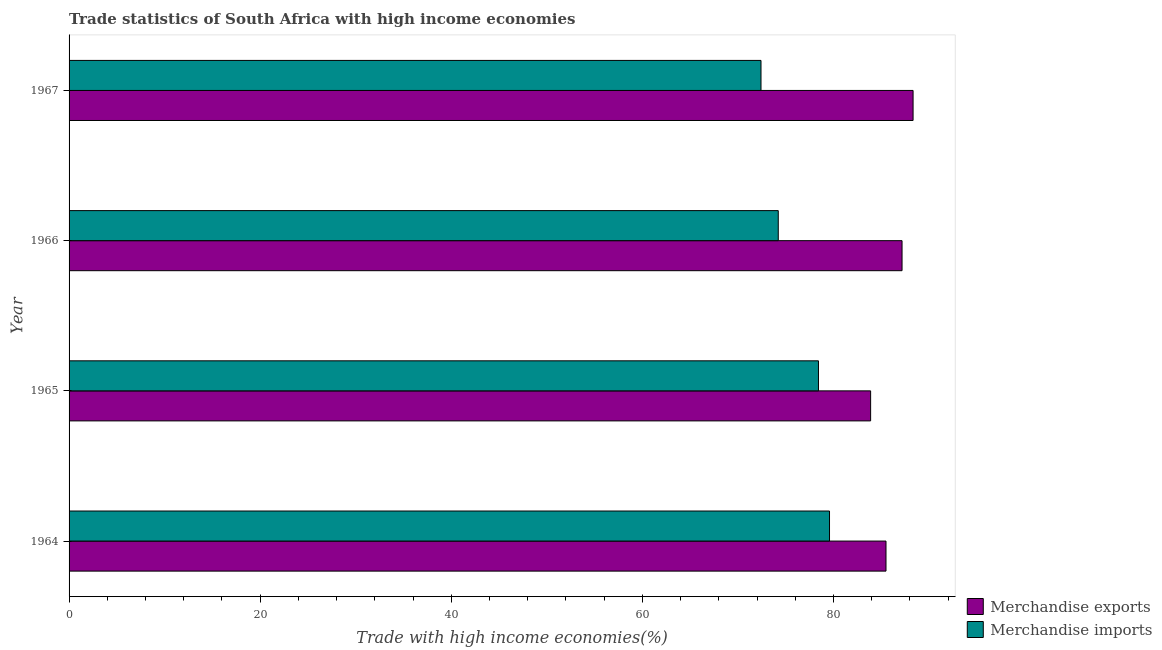How many groups of bars are there?
Offer a very short reply. 4. Are the number of bars on each tick of the Y-axis equal?
Keep it short and to the point. Yes. How many bars are there on the 2nd tick from the top?
Offer a terse response. 2. What is the label of the 1st group of bars from the top?
Provide a succinct answer. 1967. In how many cases, is the number of bars for a given year not equal to the number of legend labels?
Give a very brief answer. 0. What is the merchandise imports in 1964?
Offer a very short reply. 79.58. Across all years, what is the maximum merchandise imports?
Provide a succinct answer. 79.58. Across all years, what is the minimum merchandise exports?
Your response must be concise. 83.89. In which year was the merchandise exports maximum?
Your response must be concise. 1967. In which year was the merchandise imports minimum?
Offer a very short reply. 1967. What is the total merchandise exports in the graph?
Your answer should be very brief. 344.88. What is the difference between the merchandise exports in 1965 and that in 1966?
Keep it short and to the point. -3.29. What is the difference between the merchandise exports in 1966 and the merchandise imports in 1967?
Offer a very short reply. 14.76. What is the average merchandise imports per year?
Give a very brief answer. 76.16. In the year 1966, what is the difference between the merchandise exports and merchandise imports?
Keep it short and to the point. 12.95. What is the difference between the highest and the second highest merchandise imports?
Offer a very short reply. 1.16. What is the difference between the highest and the lowest merchandise imports?
Provide a succinct answer. 7.17. Is the sum of the merchandise exports in 1965 and 1967 greater than the maximum merchandise imports across all years?
Your answer should be very brief. Yes. What does the 2nd bar from the bottom in 1965 represents?
Your response must be concise. Merchandise imports. Are all the bars in the graph horizontal?
Make the answer very short. Yes. Does the graph contain any zero values?
Keep it short and to the point. No. Does the graph contain grids?
Your answer should be very brief. No. How many legend labels are there?
Your answer should be very brief. 2. What is the title of the graph?
Your response must be concise. Trade statistics of South Africa with high income economies. What is the label or title of the X-axis?
Your answer should be very brief. Trade with high income economies(%). What is the label or title of the Y-axis?
Give a very brief answer. Year. What is the Trade with high income economies(%) in Merchandise exports in 1964?
Your answer should be very brief. 85.49. What is the Trade with high income economies(%) in Merchandise imports in 1964?
Make the answer very short. 79.58. What is the Trade with high income economies(%) in Merchandise exports in 1965?
Provide a succinct answer. 83.89. What is the Trade with high income economies(%) in Merchandise imports in 1965?
Give a very brief answer. 78.43. What is the Trade with high income economies(%) of Merchandise exports in 1966?
Make the answer very short. 87.17. What is the Trade with high income economies(%) of Merchandise imports in 1966?
Give a very brief answer. 74.22. What is the Trade with high income economies(%) in Merchandise exports in 1967?
Ensure brevity in your answer.  88.33. What is the Trade with high income economies(%) of Merchandise imports in 1967?
Provide a succinct answer. 72.41. Across all years, what is the maximum Trade with high income economies(%) in Merchandise exports?
Your answer should be very brief. 88.33. Across all years, what is the maximum Trade with high income economies(%) in Merchandise imports?
Your answer should be very brief. 79.58. Across all years, what is the minimum Trade with high income economies(%) of Merchandise exports?
Your answer should be compact. 83.89. Across all years, what is the minimum Trade with high income economies(%) of Merchandise imports?
Your answer should be compact. 72.41. What is the total Trade with high income economies(%) of Merchandise exports in the graph?
Give a very brief answer. 344.88. What is the total Trade with high income economies(%) of Merchandise imports in the graph?
Keep it short and to the point. 304.64. What is the difference between the Trade with high income economies(%) in Merchandise exports in 1964 and that in 1965?
Keep it short and to the point. 1.61. What is the difference between the Trade with high income economies(%) of Merchandise imports in 1964 and that in 1965?
Offer a very short reply. 1.16. What is the difference between the Trade with high income economies(%) in Merchandise exports in 1964 and that in 1966?
Offer a very short reply. -1.68. What is the difference between the Trade with high income economies(%) in Merchandise imports in 1964 and that in 1966?
Make the answer very short. 5.36. What is the difference between the Trade with high income economies(%) in Merchandise exports in 1964 and that in 1967?
Provide a short and direct response. -2.83. What is the difference between the Trade with high income economies(%) in Merchandise imports in 1964 and that in 1967?
Keep it short and to the point. 7.17. What is the difference between the Trade with high income economies(%) of Merchandise exports in 1965 and that in 1966?
Ensure brevity in your answer.  -3.29. What is the difference between the Trade with high income economies(%) of Merchandise imports in 1965 and that in 1966?
Make the answer very short. 4.21. What is the difference between the Trade with high income economies(%) of Merchandise exports in 1965 and that in 1967?
Keep it short and to the point. -4.44. What is the difference between the Trade with high income economies(%) of Merchandise imports in 1965 and that in 1967?
Offer a terse response. 6.01. What is the difference between the Trade with high income economies(%) in Merchandise exports in 1966 and that in 1967?
Ensure brevity in your answer.  -1.15. What is the difference between the Trade with high income economies(%) of Merchandise imports in 1966 and that in 1967?
Keep it short and to the point. 1.81. What is the difference between the Trade with high income economies(%) of Merchandise exports in 1964 and the Trade with high income economies(%) of Merchandise imports in 1965?
Your answer should be very brief. 7.07. What is the difference between the Trade with high income economies(%) of Merchandise exports in 1964 and the Trade with high income economies(%) of Merchandise imports in 1966?
Offer a very short reply. 11.28. What is the difference between the Trade with high income economies(%) in Merchandise exports in 1964 and the Trade with high income economies(%) in Merchandise imports in 1967?
Give a very brief answer. 13.08. What is the difference between the Trade with high income economies(%) of Merchandise exports in 1965 and the Trade with high income economies(%) of Merchandise imports in 1966?
Make the answer very short. 9.67. What is the difference between the Trade with high income economies(%) in Merchandise exports in 1965 and the Trade with high income economies(%) in Merchandise imports in 1967?
Offer a terse response. 11.47. What is the difference between the Trade with high income economies(%) of Merchandise exports in 1966 and the Trade with high income economies(%) of Merchandise imports in 1967?
Keep it short and to the point. 14.76. What is the average Trade with high income economies(%) in Merchandise exports per year?
Make the answer very short. 86.22. What is the average Trade with high income economies(%) of Merchandise imports per year?
Ensure brevity in your answer.  76.16. In the year 1964, what is the difference between the Trade with high income economies(%) of Merchandise exports and Trade with high income economies(%) of Merchandise imports?
Your response must be concise. 5.91. In the year 1965, what is the difference between the Trade with high income economies(%) of Merchandise exports and Trade with high income economies(%) of Merchandise imports?
Your response must be concise. 5.46. In the year 1966, what is the difference between the Trade with high income economies(%) of Merchandise exports and Trade with high income economies(%) of Merchandise imports?
Your response must be concise. 12.95. In the year 1967, what is the difference between the Trade with high income economies(%) in Merchandise exports and Trade with high income economies(%) in Merchandise imports?
Offer a very short reply. 15.91. What is the ratio of the Trade with high income economies(%) of Merchandise exports in 1964 to that in 1965?
Give a very brief answer. 1.02. What is the ratio of the Trade with high income economies(%) in Merchandise imports in 1964 to that in 1965?
Your response must be concise. 1.01. What is the ratio of the Trade with high income economies(%) in Merchandise exports in 1964 to that in 1966?
Offer a very short reply. 0.98. What is the ratio of the Trade with high income economies(%) of Merchandise imports in 1964 to that in 1966?
Offer a terse response. 1.07. What is the ratio of the Trade with high income economies(%) in Merchandise exports in 1964 to that in 1967?
Give a very brief answer. 0.97. What is the ratio of the Trade with high income economies(%) of Merchandise imports in 1964 to that in 1967?
Provide a succinct answer. 1.1. What is the ratio of the Trade with high income economies(%) of Merchandise exports in 1965 to that in 1966?
Offer a very short reply. 0.96. What is the ratio of the Trade with high income economies(%) of Merchandise imports in 1965 to that in 1966?
Your answer should be very brief. 1.06. What is the ratio of the Trade with high income economies(%) in Merchandise exports in 1965 to that in 1967?
Ensure brevity in your answer.  0.95. What is the ratio of the Trade with high income economies(%) of Merchandise imports in 1965 to that in 1967?
Your answer should be very brief. 1.08. What is the ratio of the Trade with high income economies(%) in Merchandise exports in 1966 to that in 1967?
Your response must be concise. 0.99. What is the ratio of the Trade with high income economies(%) in Merchandise imports in 1966 to that in 1967?
Make the answer very short. 1.02. What is the difference between the highest and the second highest Trade with high income economies(%) of Merchandise exports?
Provide a succinct answer. 1.15. What is the difference between the highest and the second highest Trade with high income economies(%) of Merchandise imports?
Keep it short and to the point. 1.16. What is the difference between the highest and the lowest Trade with high income economies(%) of Merchandise exports?
Keep it short and to the point. 4.44. What is the difference between the highest and the lowest Trade with high income economies(%) in Merchandise imports?
Keep it short and to the point. 7.17. 